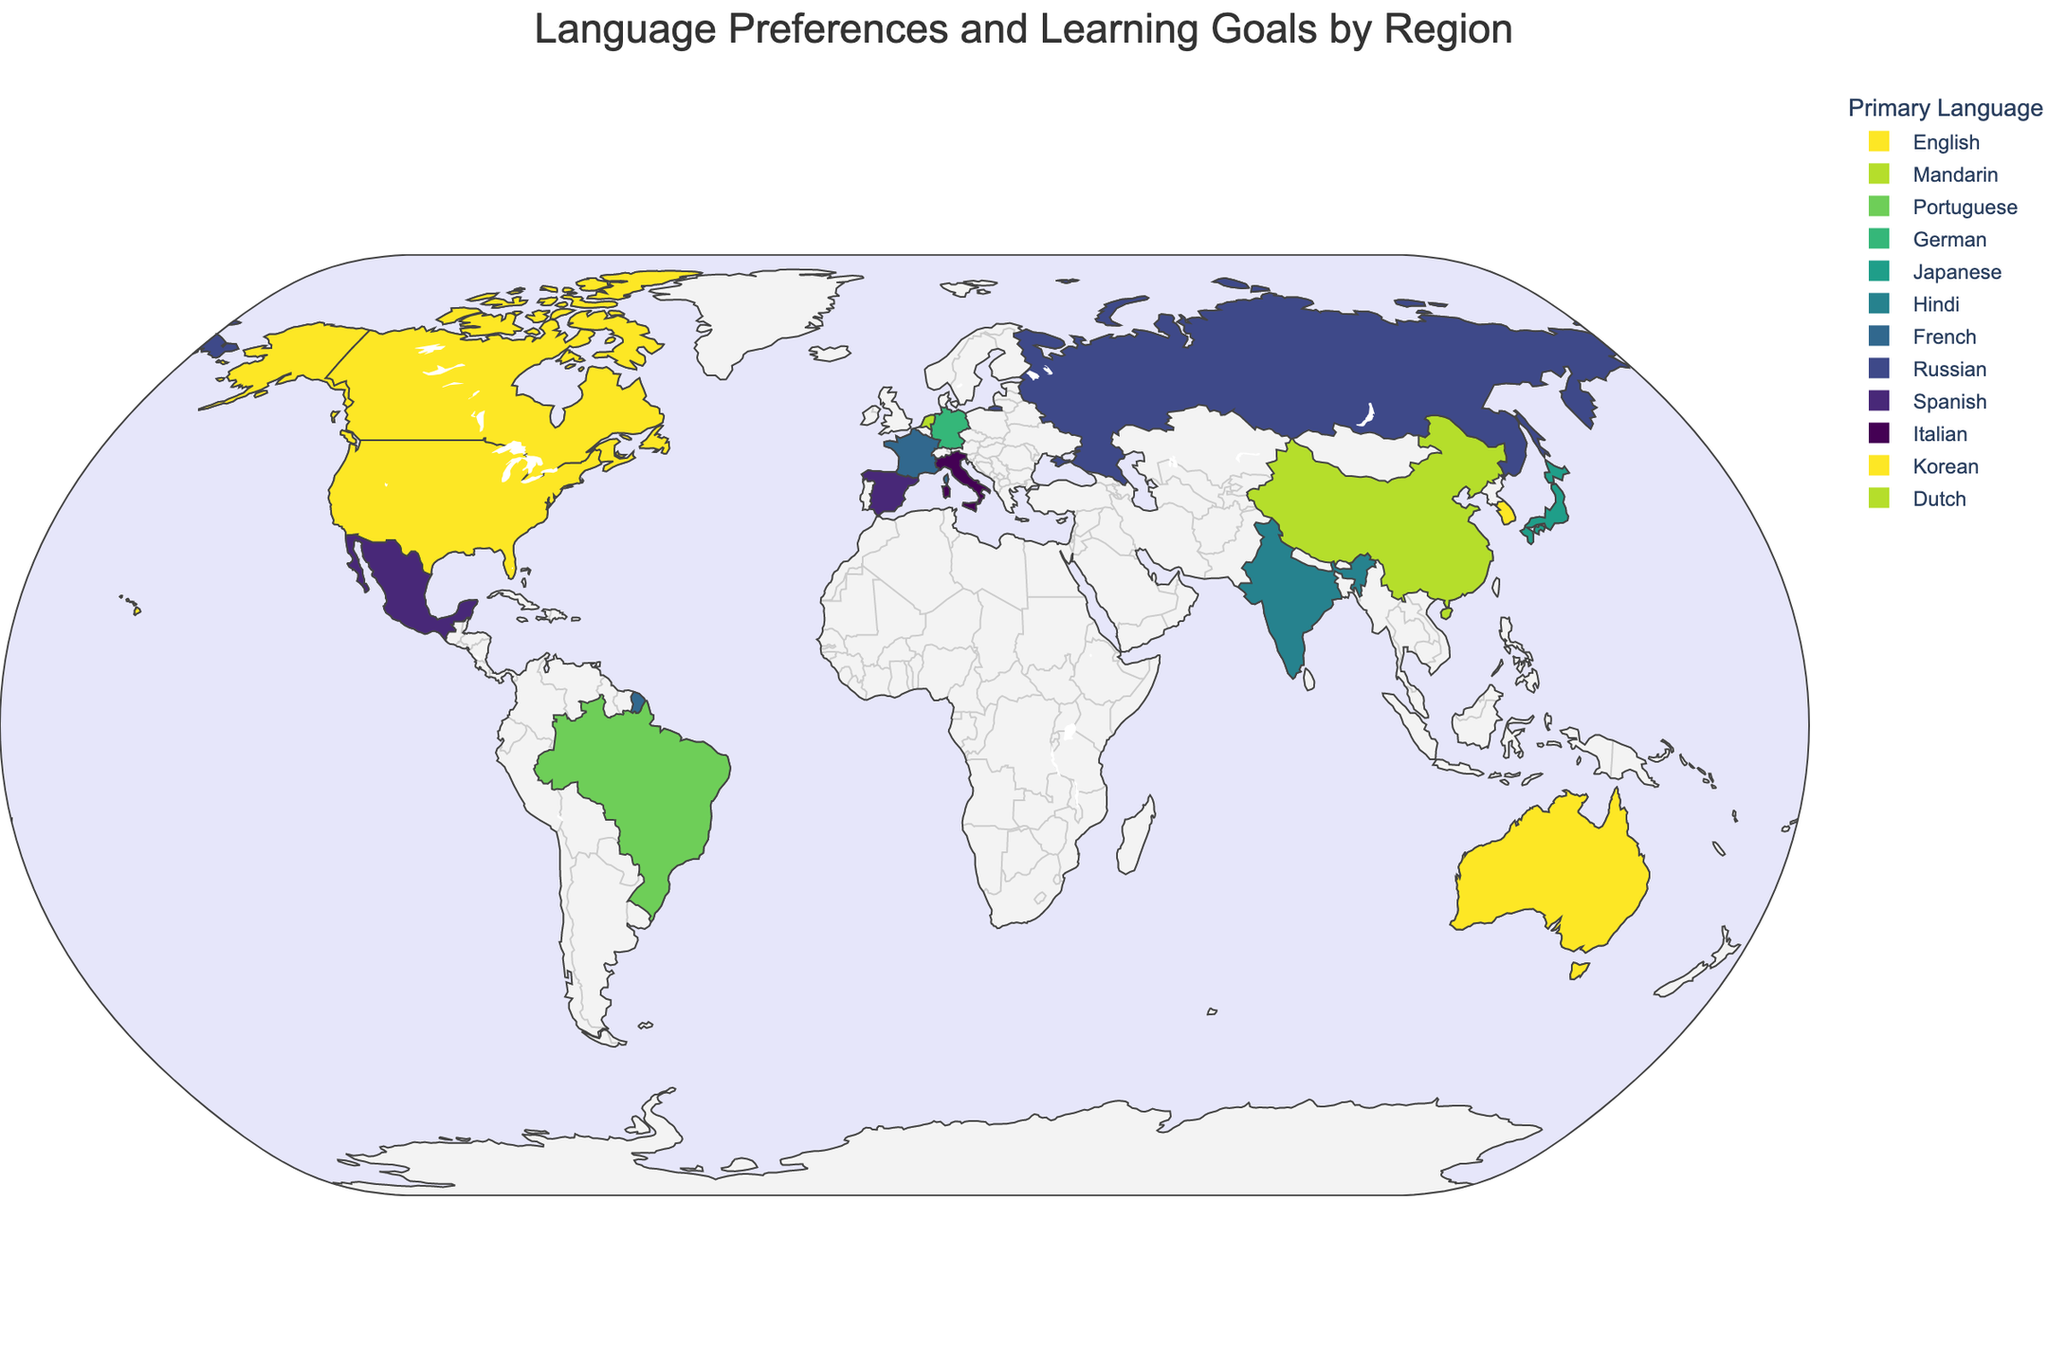Which countries have English as their secondary language? To find this, we need to look at the "Secondary Language" information for each region on the map. The countries with English as their secondary language include China, Brazil, Germany, Japan, India, France, Russia, Mexico, Italy, South Korea, and Netherlands.
Answer: China, Brazil, Germany, Japan, India, France, Russia, Mexico, Italy, South Korea, Netherlands Which region has "Business Communication" as the top learning goal? To identify this, we need to look at the "Top Learning Goal" for each region. The region with "Business Communication" as the top learning goal is the United States.
Answer: United States What are the primary languages spoken in Europe? To answer this, we look for regions in Europe and note their primary languages. The countries in Europe included are Germany, France, Russia, Italy, Spain, and Netherlands. Their primary languages are German, French, Russian, Italian, Spanish, and Dutch respectively.
Answer: German, French, Russian, Italian, Spanish, Dutch How many regions have "Career Advancement" or "Professional Development" as their top learning goal? Check each region's "Top Learning Goal" and count those that match either "Career Advancement" or "Professional Development". Brazil has "Career Advancement" and Mexico has "Professional Development". There are 2 regions in total.
Answer: 2 Which regions have "English" both as a primary or secondary language? This requires checking both the "Primary Language" and "Secondary Language" for each region. The regions are the United States, Canada, India, and Australia for primary, and the United States, China, Brazil, Germany, Japan, India, France, Russia, Mexico, Italy, South Korea, and Netherlands for secondary. Removing duplicates, the results are: United States, Canada, India, Australia, China, Brazil, Germany, Japan, France, Russia, Mexico, Italy, South Korea, Netherlands.
Answer: United States, Canada, India, Australia, China, Brazil, Germany, Japan, France, Russia, Mexico, Italy, South Korea, Netherlands What are the common learning goals in Asia? To determine this, we need to look at the learning goals of the regions in Asia: China, Japan, India, and South Korea. China's top goal is "Academic Purposes", Japan's is "Anime and Pop Culture", India's is "Higher Education", and South Korea's is "K-pop and Entertainment".
Answer: Academic Purposes, Anime and Pop Culture, Higher Education, K-pop and Entertainment Which region has the simplest combination of primary and secondary languages (i.e. languages that are the most commonly spoken worldwide)? To find the simplest combination, assess which primary and secondary languages are globally dominant. English is the most widely spoken language. The regions where English is either primary or secondary are the United States, Canada, Australia, and India for primary, and several other regions for secondary. The simplest combination would be a single or highly familiar pair. Consider the United States (English primary, Spanish secondary) or Canada (English primary, French secondary).
Answer: United States What unique learning goals can we see in Europe? Identify the "Top Learning Goal" for each European region: Germany (Technical Vocabulary), France (Literature and Arts), Russia (Scientific Research), Italy (Culinary Arts), Spain (Teaching Abroad), Netherlands (Multilingual Business). Note the variety of unique learning goals mentioned.
Answer: Technical Vocabulary, Literature and Arts, Scientific Research, Culinary Arts, Teaching Abroad, Multilingual Business 